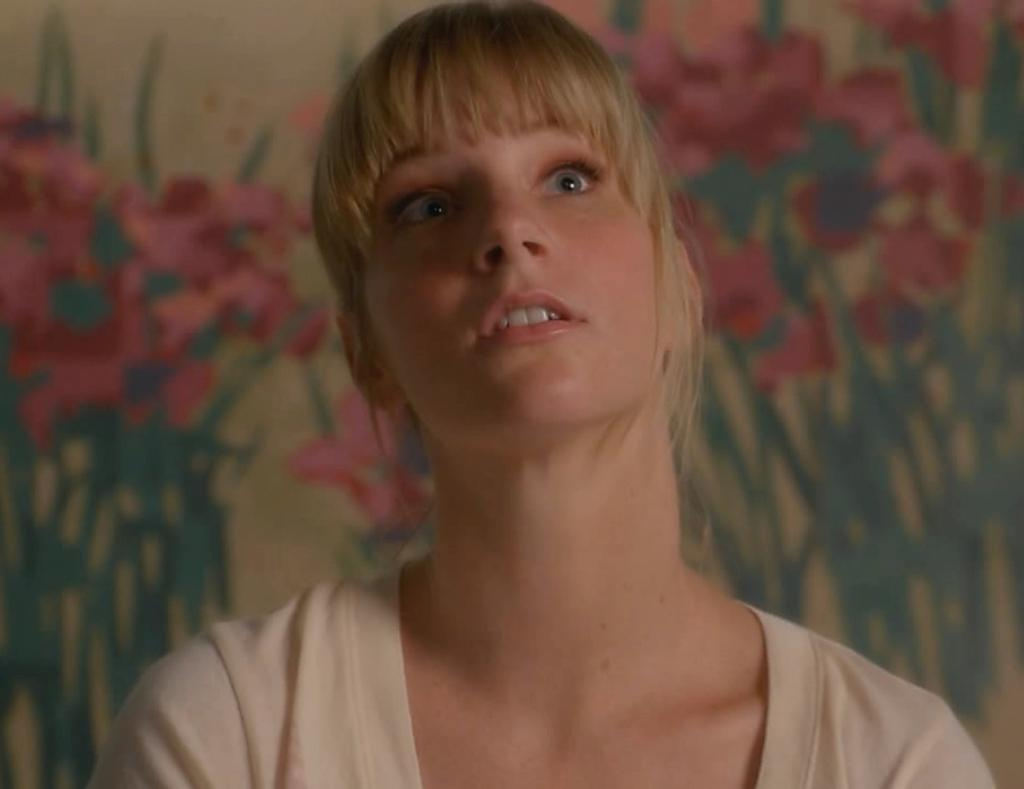Who is present in the image? There is a woman in the image. What can be seen in the background of the image? There is a wall in the background of the image. What is depicted on the wall? The wall has a painting of plants with flowers. Can you see any bees buzzing around the flowers in the painting? There are no bees present in the image, as it only features a painting of plants with flowers. What type of quartz can be seen in the woman's hand in the image? There is no quartz visible in the image, as the woman is not holding any object. 